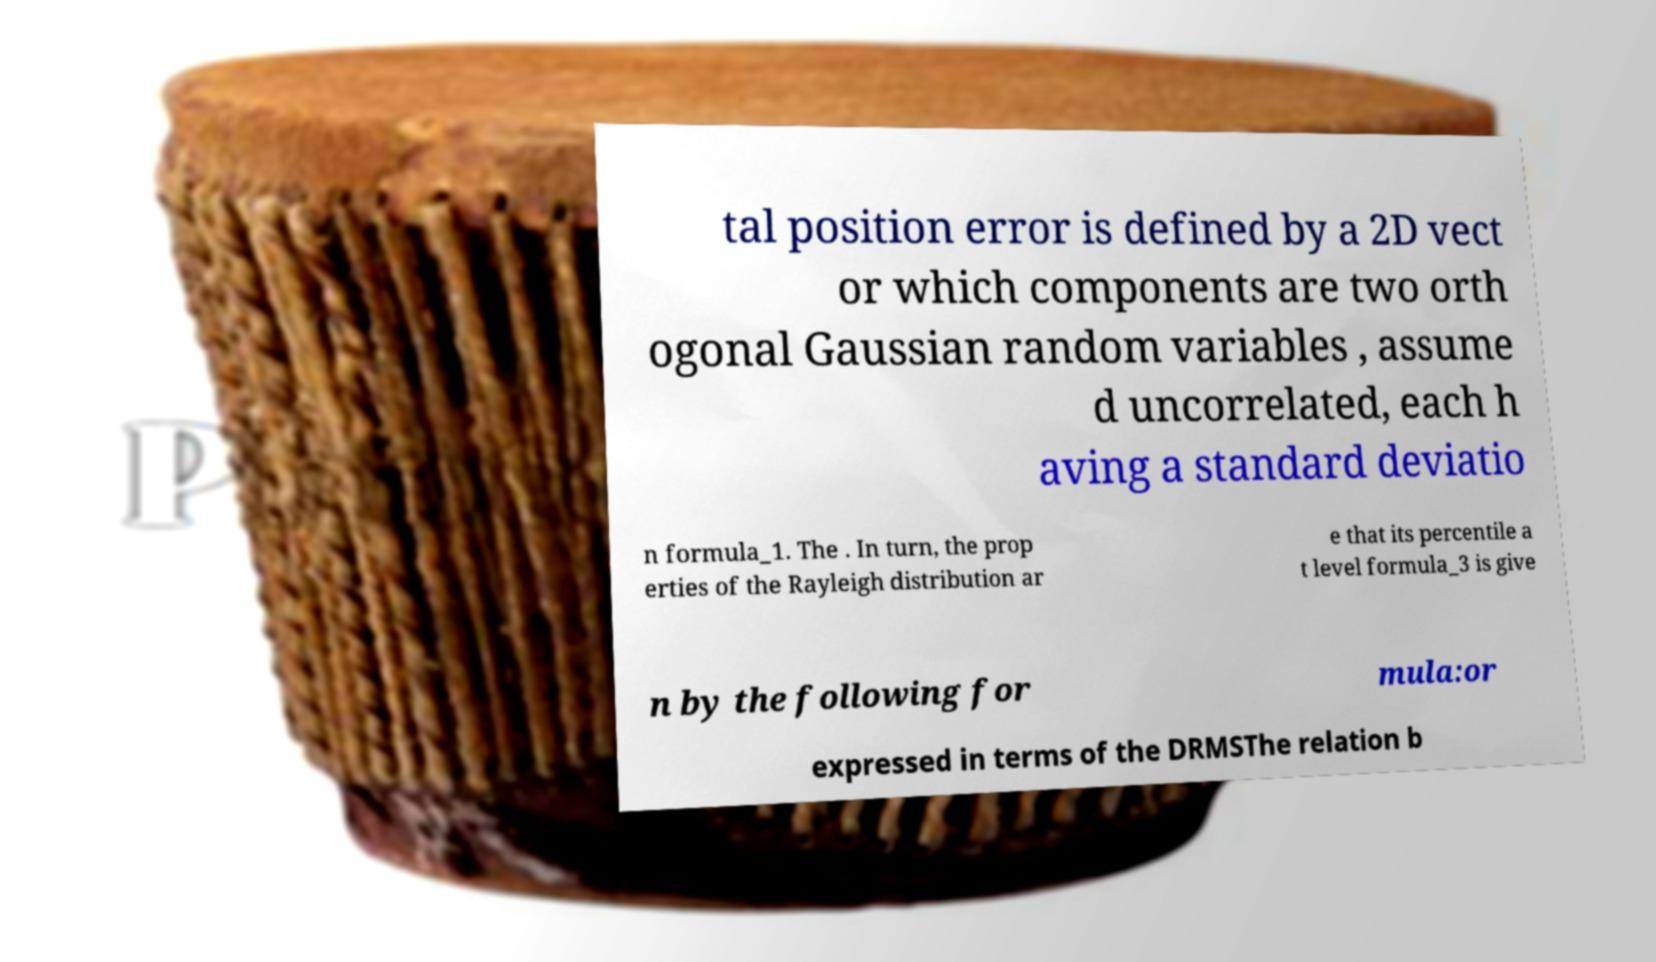Could you assist in decoding the text presented in this image and type it out clearly? tal position error is defined by a 2D vect or which components are two orth ogonal Gaussian random variables , assume d uncorrelated, each h aving a standard deviatio n formula_1. The . In turn, the prop erties of the Rayleigh distribution ar e that its percentile a t level formula_3 is give n by the following for mula:or expressed in terms of the DRMSThe relation b 